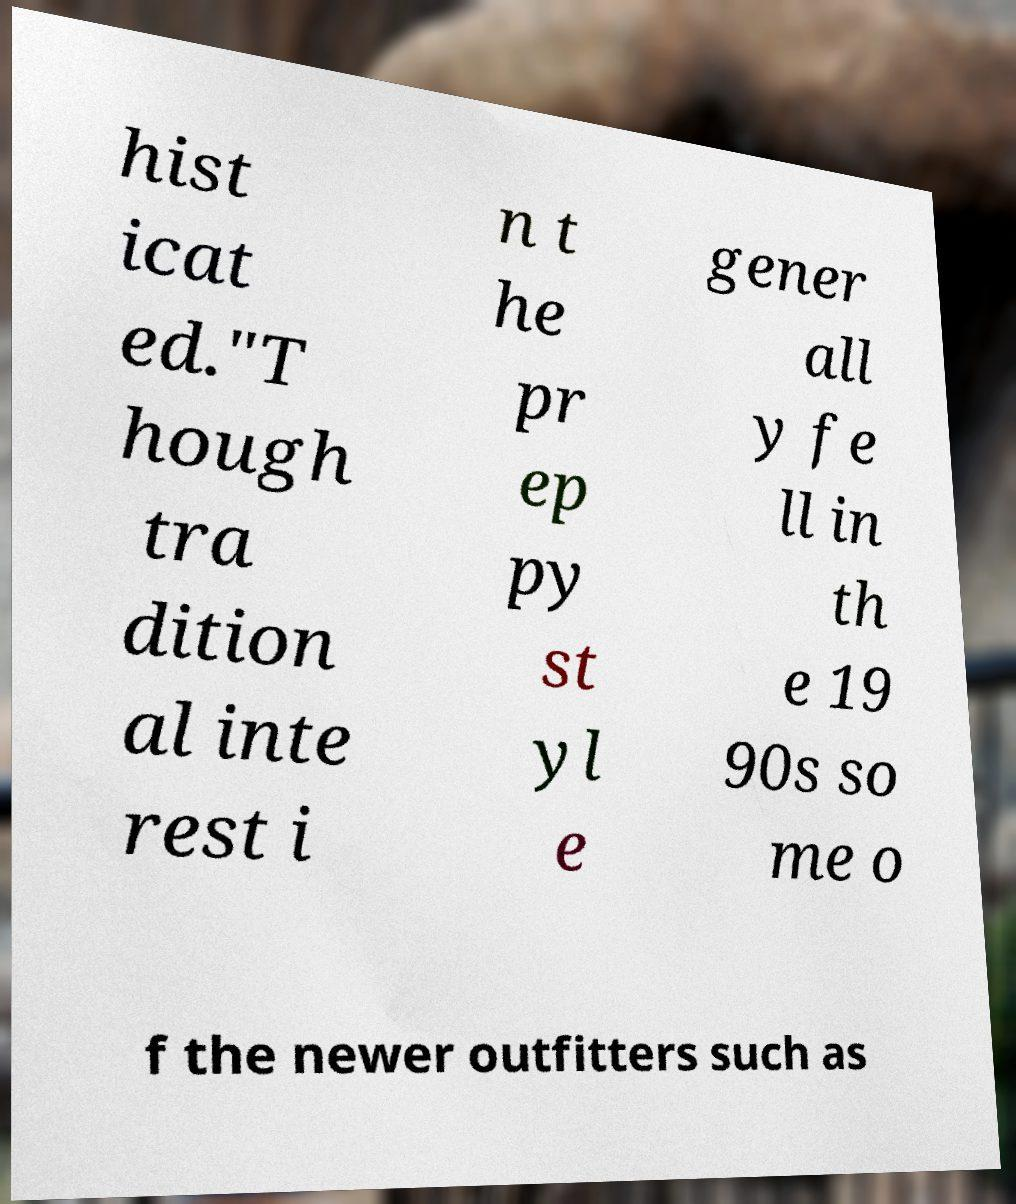Can you read and provide the text displayed in the image?This photo seems to have some interesting text. Can you extract and type it out for me? hist icat ed."T hough tra dition al inte rest i n t he pr ep py st yl e gener all y fe ll in th e 19 90s so me o f the newer outfitters such as 